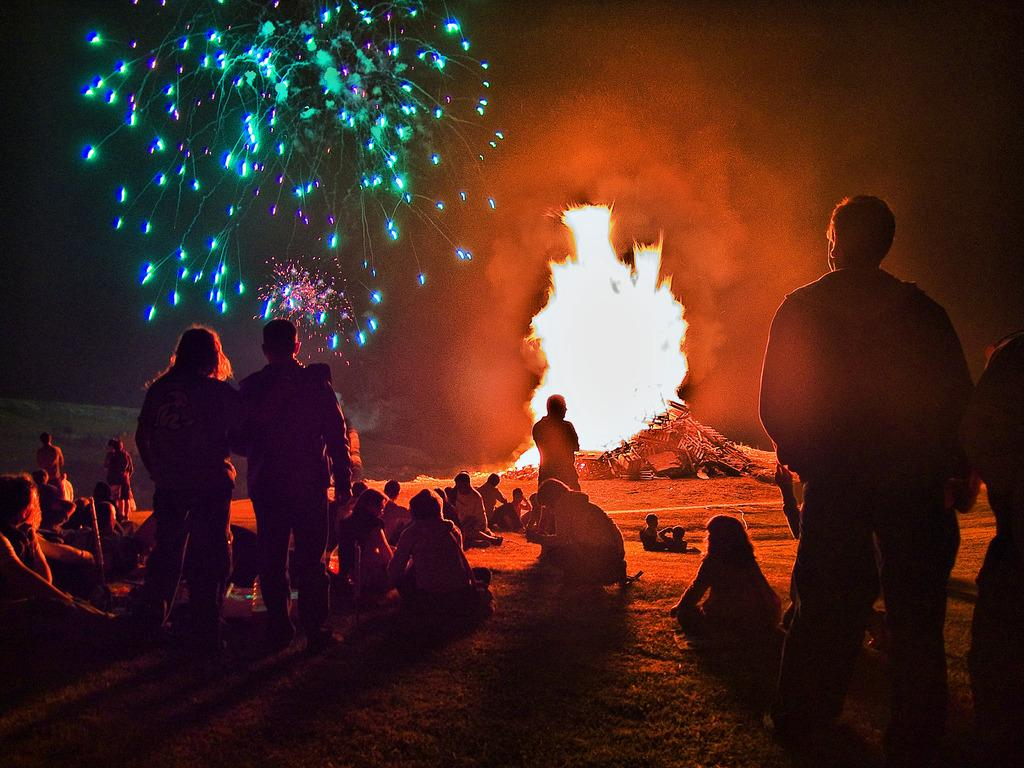How many people are in the image? There is a group of persons in the image. What can be seen in the image besides the group of persons? There is fire visible in the image, and there are lights present as well. What is the color of the background in the image? The background of the image is dark. What type of substance is being used as fuel for the vacation in the image? There is no mention of a vacation or fuel in the image; it features a group of persons, fire, and lights. 